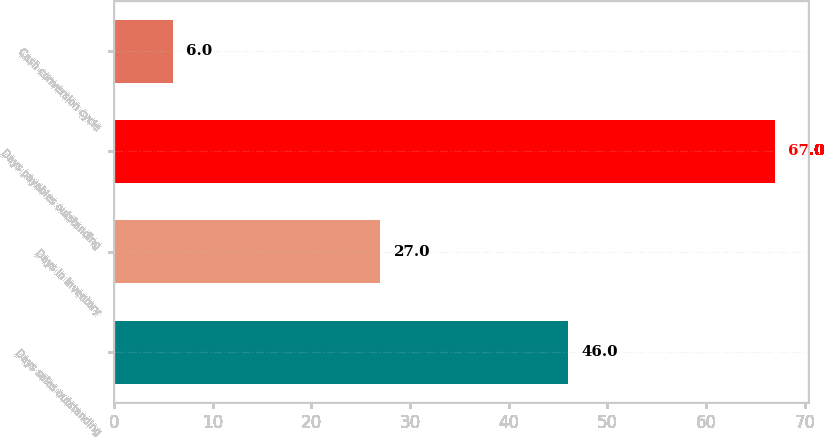<chart> <loc_0><loc_0><loc_500><loc_500><bar_chart><fcel>Days sales outstanding<fcel>Days in inventory<fcel>Days payables outstanding<fcel>Cash conversion cycle<nl><fcel>46<fcel>27<fcel>67<fcel>6<nl></chart> 